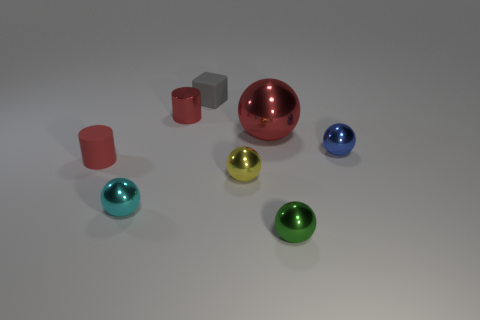Subtract all yellow balls. How many balls are left? 4 Subtract all red balls. How many balls are left? 4 Subtract all purple balls. Subtract all purple cubes. How many balls are left? 5 Add 2 big brown cubes. How many objects exist? 10 Subtract all blocks. How many objects are left? 7 Add 3 blue shiny things. How many blue shiny things are left? 4 Add 3 small yellow shiny spheres. How many small yellow shiny spheres exist? 4 Subtract 0 purple cylinders. How many objects are left? 8 Subtract all cyan objects. Subtract all small things. How many objects are left? 0 